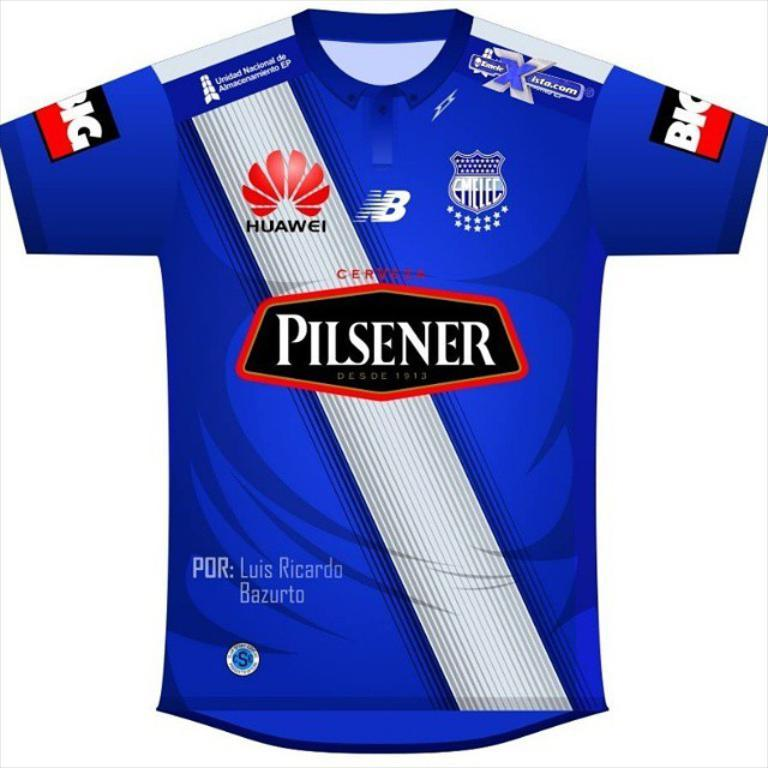<image>
Give a short and clear explanation of the subsequent image. A blue jersey has the Pilsener logo on it. 